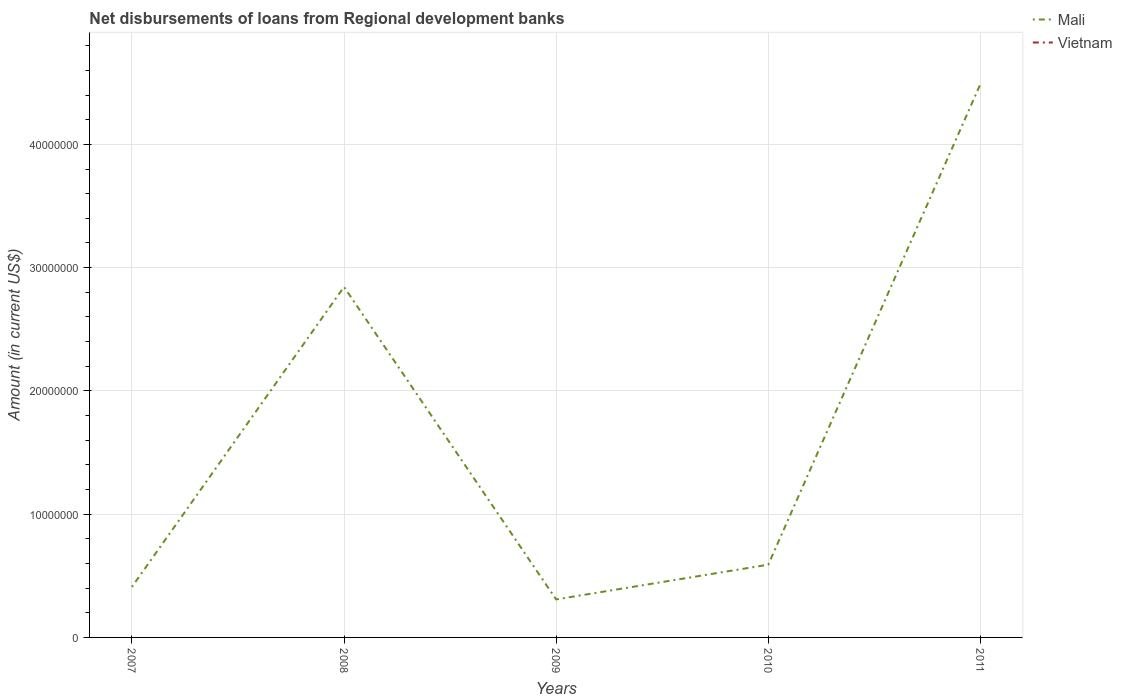How many different coloured lines are there?
Offer a terse response. 1. Does the line corresponding to Vietnam intersect with the line corresponding to Mali?
Keep it short and to the point. No. Across all years, what is the maximum amount of disbursements of loans from regional development banks in Mali?
Your answer should be compact. 3.08e+06. What is the total amount of disbursements of loans from regional development banks in Mali in the graph?
Offer a terse response. -2.82e+06. What is the difference between the highest and the second highest amount of disbursements of loans from regional development banks in Mali?
Provide a succinct answer. 4.18e+07. What is the difference between the highest and the lowest amount of disbursements of loans from regional development banks in Vietnam?
Ensure brevity in your answer.  0. How many years are there in the graph?
Keep it short and to the point. 5. Does the graph contain any zero values?
Give a very brief answer. Yes. Where does the legend appear in the graph?
Provide a short and direct response. Top right. How are the legend labels stacked?
Your answer should be compact. Vertical. What is the title of the graph?
Keep it short and to the point. Net disbursements of loans from Regional development banks. What is the label or title of the X-axis?
Keep it short and to the point. Years. What is the label or title of the Y-axis?
Keep it short and to the point. Amount (in current US$). What is the Amount (in current US$) of Mali in 2007?
Provide a short and direct response. 4.09e+06. What is the Amount (in current US$) of Mali in 2008?
Your response must be concise. 2.84e+07. What is the Amount (in current US$) in Vietnam in 2008?
Ensure brevity in your answer.  0. What is the Amount (in current US$) of Mali in 2009?
Make the answer very short. 3.08e+06. What is the Amount (in current US$) in Mali in 2010?
Your answer should be very brief. 5.90e+06. What is the Amount (in current US$) of Mali in 2011?
Your response must be concise. 4.49e+07. What is the Amount (in current US$) of Vietnam in 2011?
Give a very brief answer. 0. Across all years, what is the maximum Amount (in current US$) of Mali?
Give a very brief answer. 4.49e+07. Across all years, what is the minimum Amount (in current US$) in Mali?
Your answer should be compact. 3.08e+06. What is the total Amount (in current US$) in Mali in the graph?
Offer a very short reply. 8.64e+07. What is the total Amount (in current US$) of Vietnam in the graph?
Ensure brevity in your answer.  0. What is the difference between the Amount (in current US$) of Mali in 2007 and that in 2008?
Make the answer very short. -2.43e+07. What is the difference between the Amount (in current US$) in Mali in 2007 and that in 2009?
Your response must be concise. 1.01e+06. What is the difference between the Amount (in current US$) in Mali in 2007 and that in 2010?
Provide a short and direct response. -1.81e+06. What is the difference between the Amount (in current US$) in Mali in 2007 and that in 2011?
Make the answer very short. -4.08e+07. What is the difference between the Amount (in current US$) of Mali in 2008 and that in 2009?
Give a very brief answer. 2.54e+07. What is the difference between the Amount (in current US$) of Mali in 2008 and that in 2010?
Provide a succinct answer. 2.25e+07. What is the difference between the Amount (in current US$) of Mali in 2008 and that in 2011?
Give a very brief answer. -1.64e+07. What is the difference between the Amount (in current US$) in Mali in 2009 and that in 2010?
Offer a very short reply. -2.82e+06. What is the difference between the Amount (in current US$) of Mali in 2009 and that in 2011?
Your answer should be compact. -4.18e+07. What is the difference between the Amount (in current US$) in Mali in 2010 and that in 2011?
Your response must be concise. -3.90e+07. What is the average Amount (in current US$) in Mali per year?
Keep it short and to the point. 1.73e+07. What is the ratio of the Amount (in current US$) in Mali in 2007 to that in 2008?
Offer a very short reply. 0.14. What is the ratio of the Amount (in current US$) in Mali in 2007 to that in 2009?
Offer a terse response. 1.33. What is the ratio of the Amount (in current US$) of Mali in 2007 to that in 2010?
Your answer should be very brief. 0.69. What is the ratio of the Amount (in current US$) in Mali in 2007 to that in 2011?
Provide a short and direct response. 0.09. What is the ratio of the Amount (in current US$) in Mali in 2008 to that in 2009?
Make the answer very short. 9.22. What is the ratio of the Amount (in current US$) in Mali in 2008 to that in 2010?
Give a very brief answer. 4.82. What is the ratio of the Amount (in current US$) in Mali in 2008 to that in 2011?
Provide a succinct answer. 0.63. What is the ratio of the Amount (in current US$) in Mali in 2009 to that in 2010?
Your answer should be compact. 0.52. What is the ratio of the Amount (in current US$) in Mali in 2009 to that in 2011?
Keep it short and to the point. 0.07. What is the ratio of the Amount (in current US$) of Mali in 2010 to that in 2011?
Make the answer very short. 0.13. What is the difference between the highest and the second highest Amount (in current US$) in Mali?
Give a very brief answer. 1.64e+07. What is the difference between the highest and the lowest Amount (in current US$) of Mali?
Your answer should be very brief. 4.18e+07. 